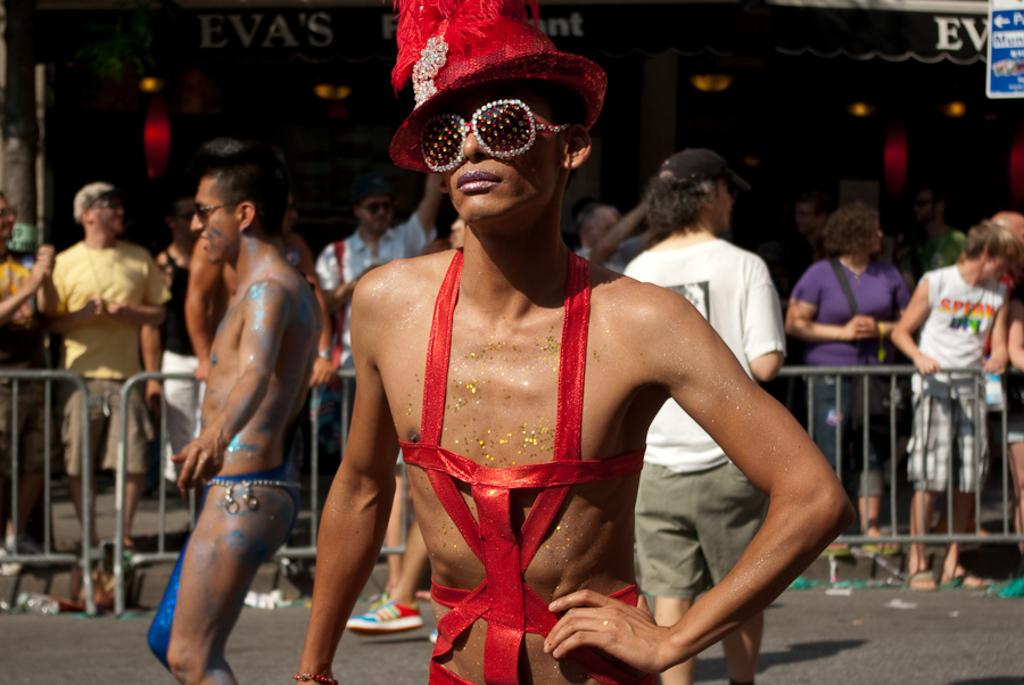How many people are standing on the path in the image? There are three people standing on the path in the image. What can be seen in the image besides the people on the path? There are barricades, people at the back, lights, and a signboard visible in the image. Where is the signboard located in the image? The signboard is on the right side of the image. What type of hose is being used to water the plants in the image? There are no plants or hoses visible in the image. How is the string being used in the image? There is no string present in the image. 